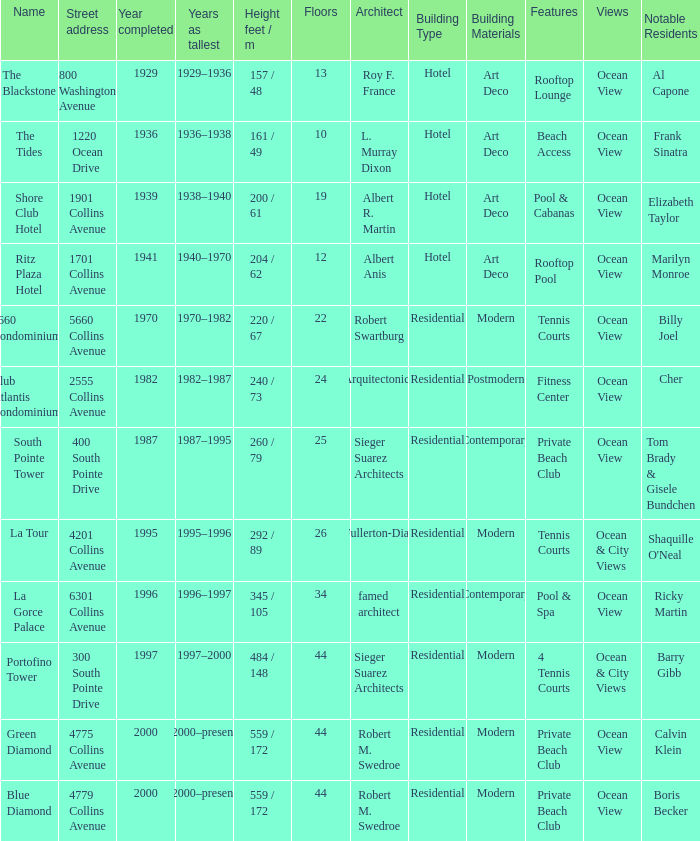How many years was the building with 24 floors the tallest? 1982–1987. 